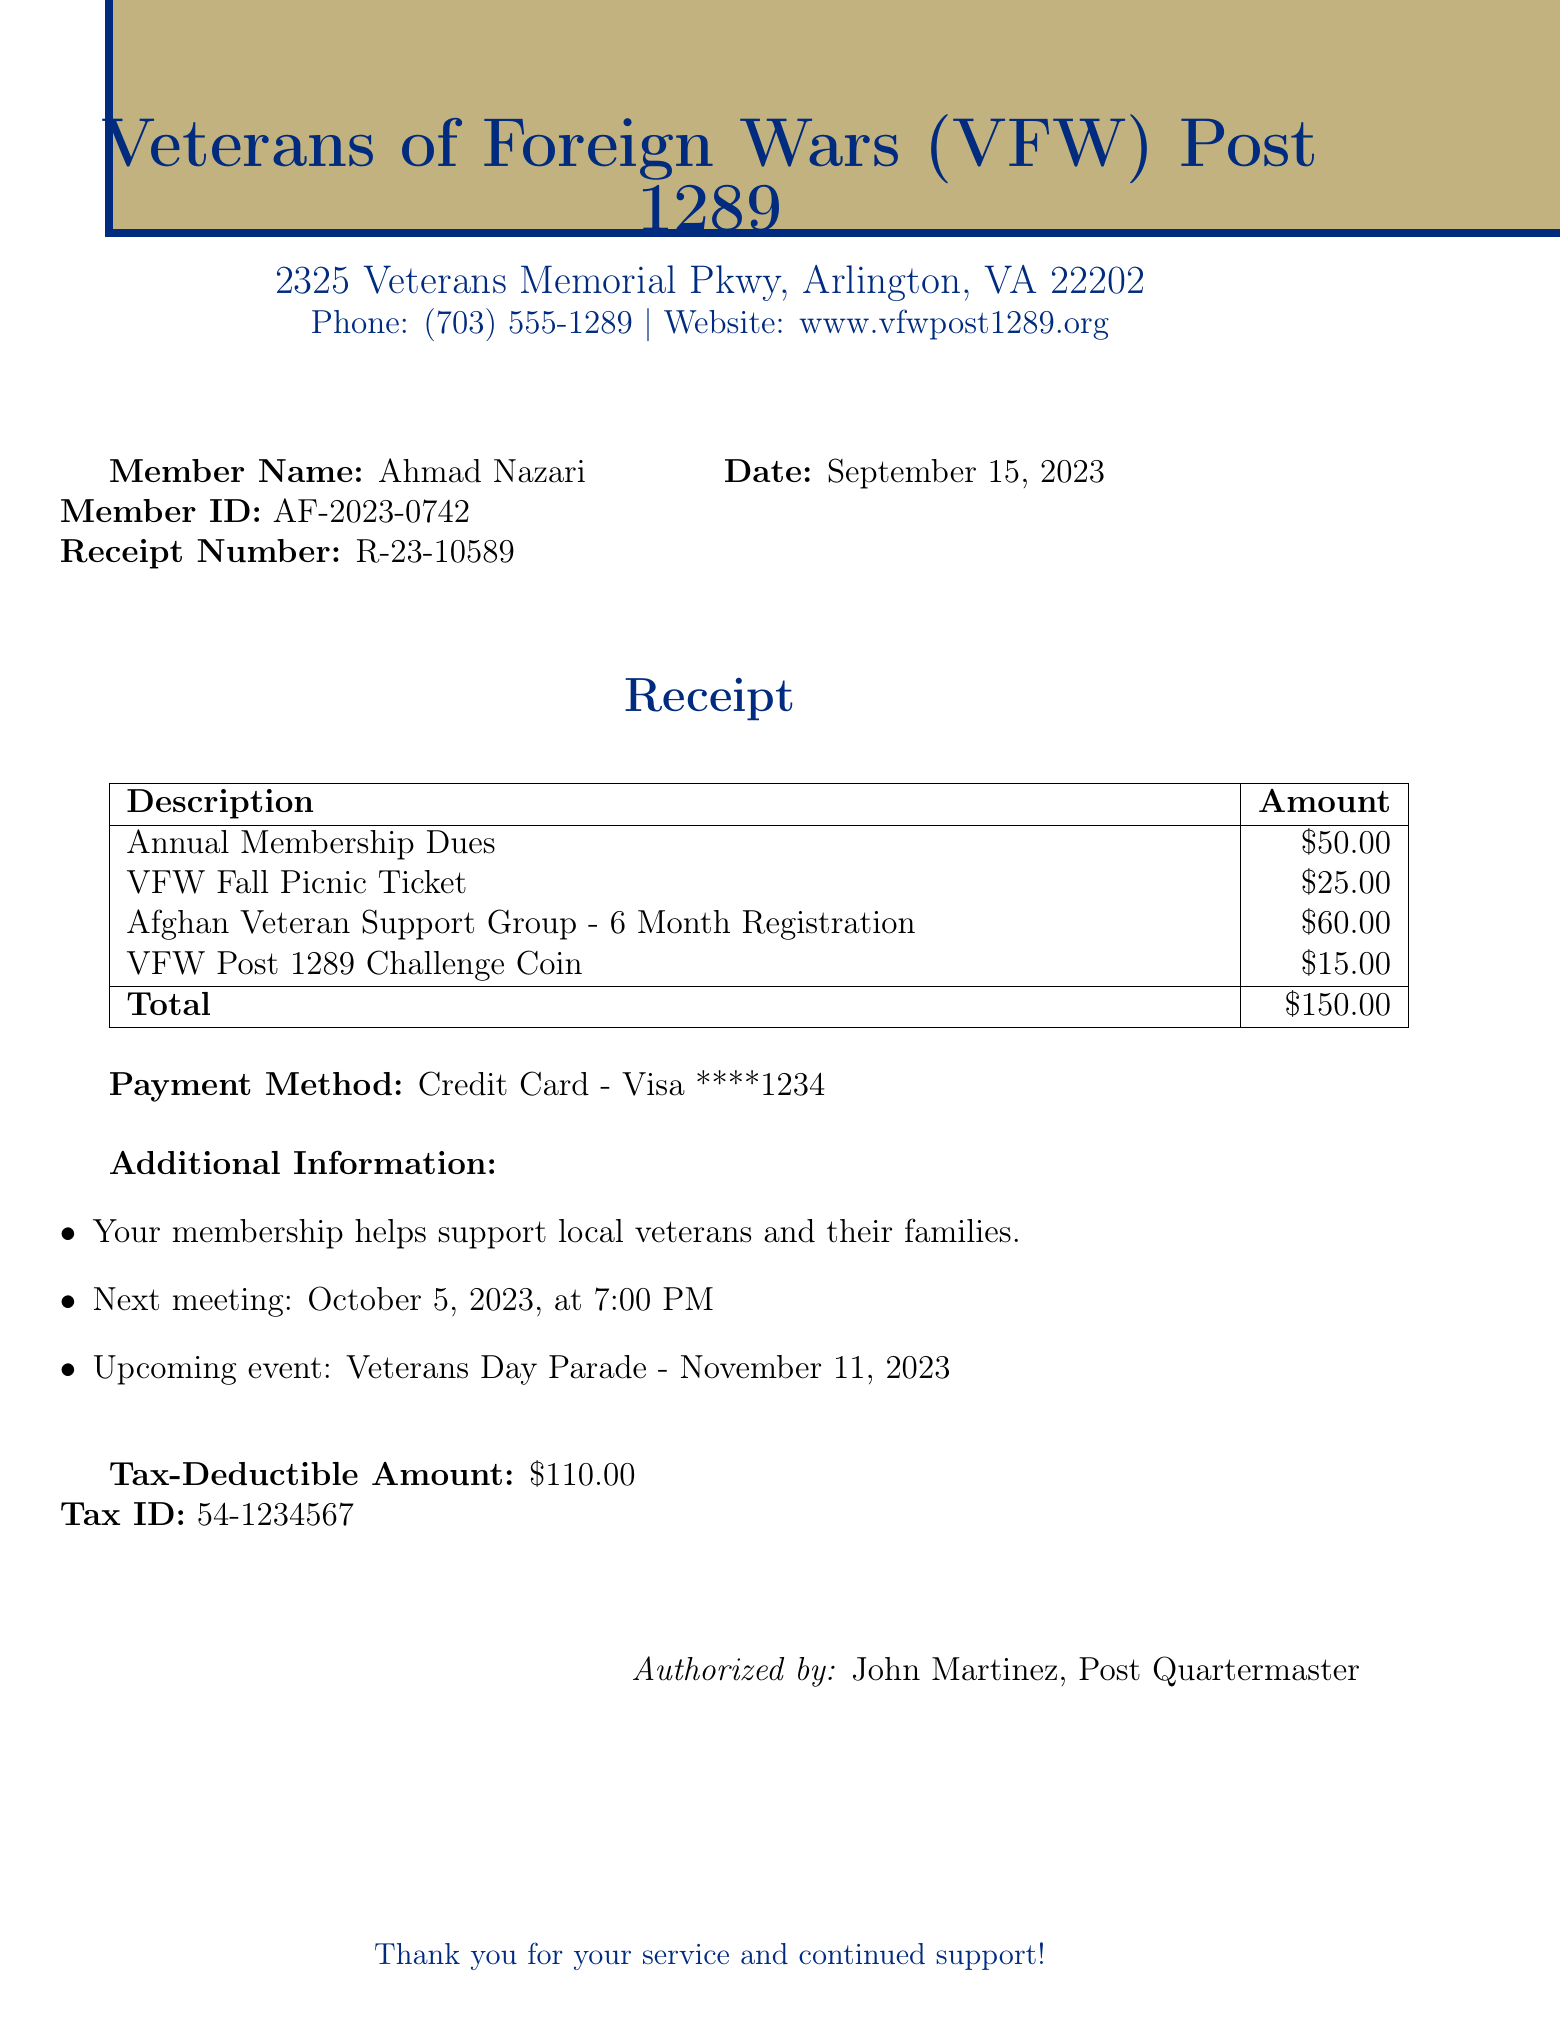What is the name of the organization? The name of the organization is found at the top of the document.
Answer: Veterans of Foreign Wars (VFW) Post 1289 What is the total amount due? The total amount is calculated from the items listed and is shown at the bottom of the table.
Answer: $150.00 What is the date of the receipt? The date is listed next to the receipt number on the document.
Answer: September 15, 2023 How much is the tax-deductible amount? The tax-deductible amount is specified as a separate item near the end of the document.
Answer: $110.00 Who is the authorized person listed on the receipt? The authorized person's name is mentioned at the end of the document.
Answer: John Martinez What payment method was used? The payment method is noted in the "Payment Method" section of the receipt.
Answer: Credit Card - Visa ****1234 How many items are listed in the receipt? The number of items can be counted from the table in the document.
Answer: 4 What is the next meeting date? The date for the next meeting is stated in the additional information section.
Answer: October 5, 2023 What is the member ID for Ahmad Nazari? The member ID is listed alongside Ahmad Nazari's name in the document.
Answer: AF-2023-0742 